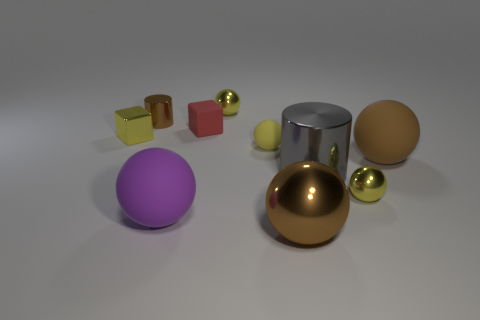What is the shape of the other big object that is the same material as the big gray object?
Your response must be concise. Sphere. What number of red things are either matte things or small metallic cylinders?
Provide a short and direct response. 1. There is a big cylinder; are there any yellow things in front of it?
Give a very brief answer. Yes. Do the yellow metallic thing that is behind the small red block and the metal object left of the tiny cylinder have the same shape?
Provide a succinct answer. No. There is a large purple thing that is the same shape as the yellow rubber thing; what is its material?
Keep it short and to the point. Rubber. How many balls are either red objects or tiny brown metal objects?
Your response must be concise. 0. How many large purple spheres are the same material as the small red block?
Provide a short and direct response. 1. Are the sphere on the left side of the tiny rubber cube and the yellow object that is behind the red object made of the same material?
Keep it short and to the point. No. There is a big rubber sphere that is left of the yellow shiny sphere in front of the brown rubber sphere; what number of brown things are behind it?
Make the answer very short. 2. Do the metal cylinder that is left of the red block and the large rubber thing that is on the left side of the big gray cylinder have the same color?
Offer a terse response. No. 